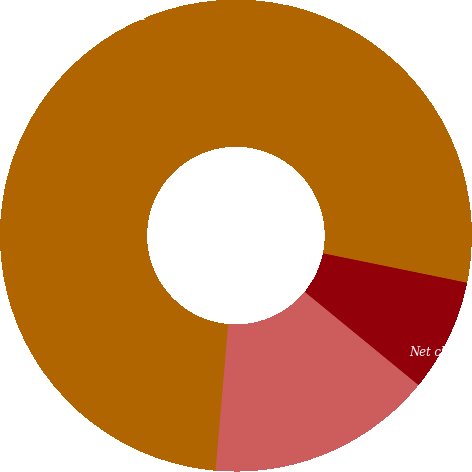Convert chart to OTSL. <chart><loc_0><loc_0><loc_500><loc_500><pie_chart><fcel>Year Ended December 31<fcel>Net charges to costs and<fcel>Write-offs<fcel>Other 1<nl><fcel>76.84%<fcel>7.72%<fcel>15.4%<fcel>0.04%<nl></chart> 